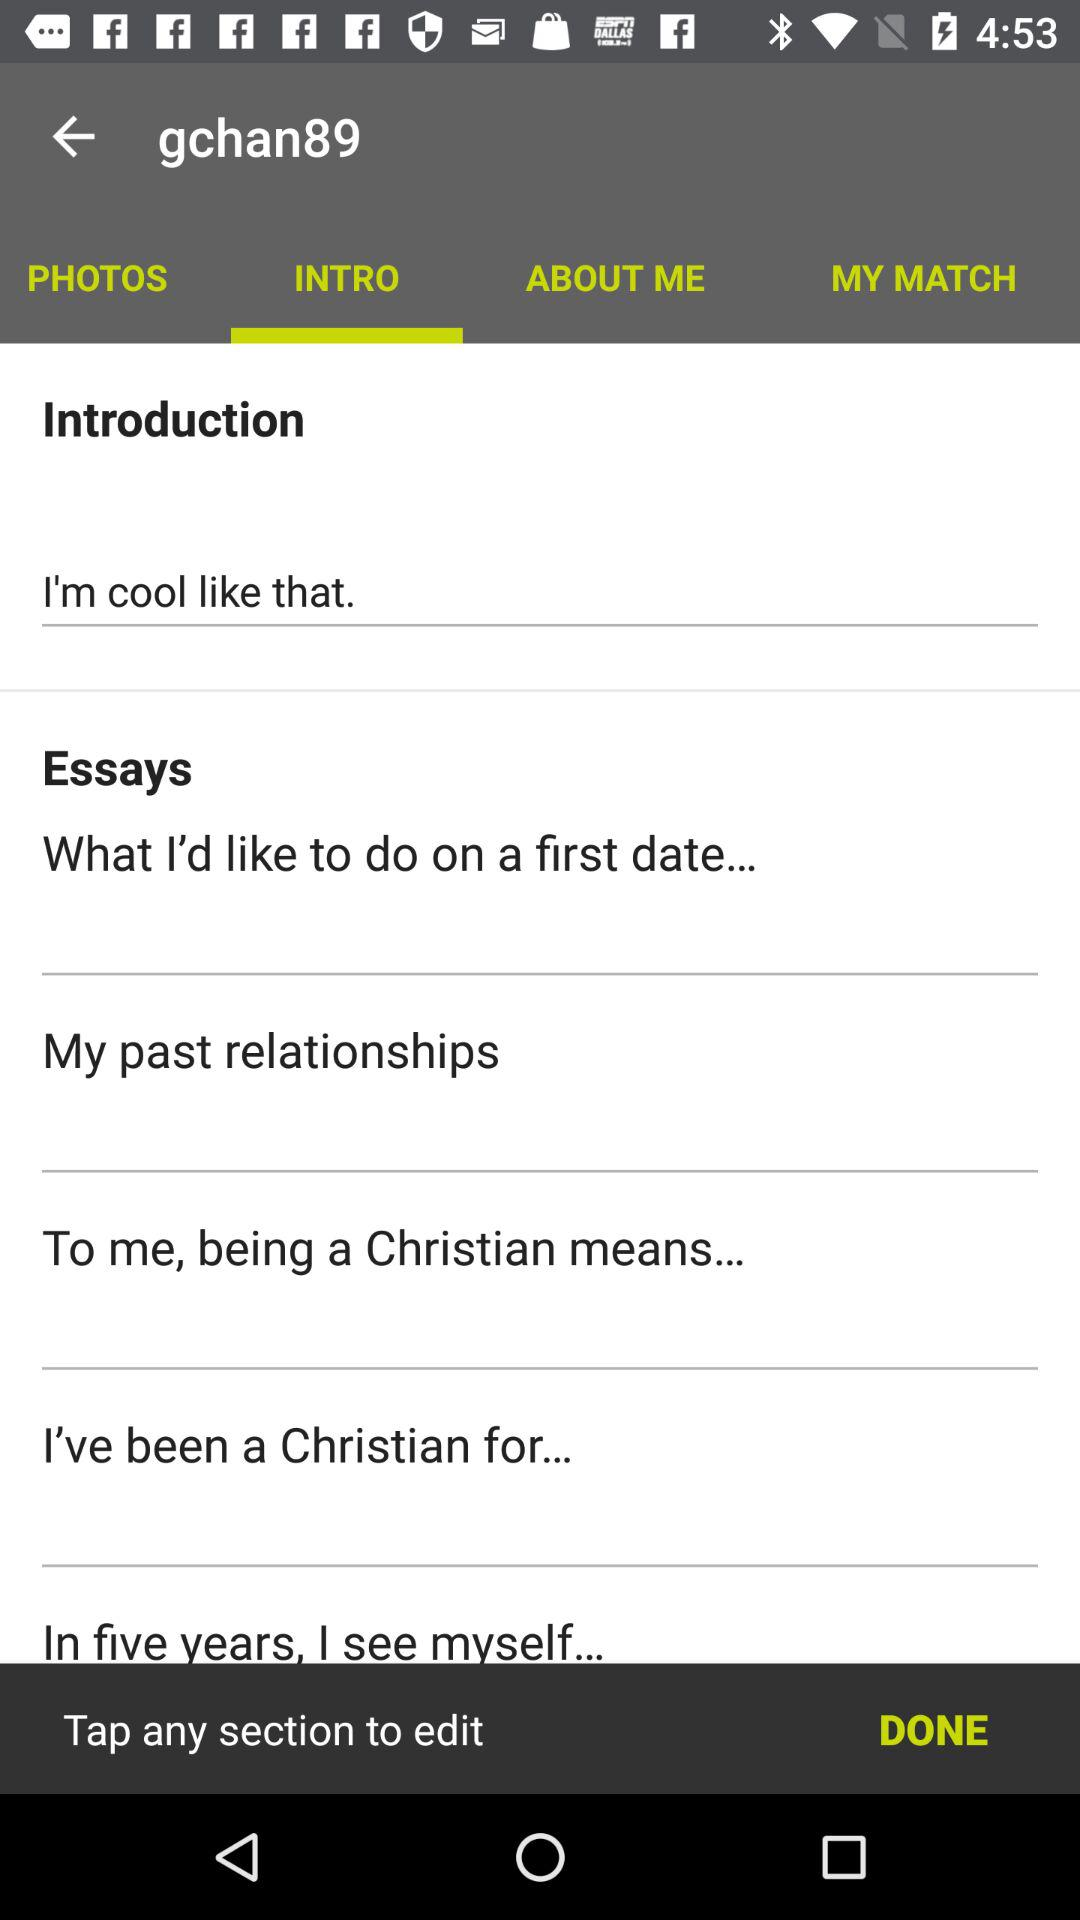What are the essay names? The essay names are "What I'd like to do on a first date..."; "My past relationships"; "To me, being a Christian means..."; "I've been a Christian for..." and "In five years, I see myself...". 